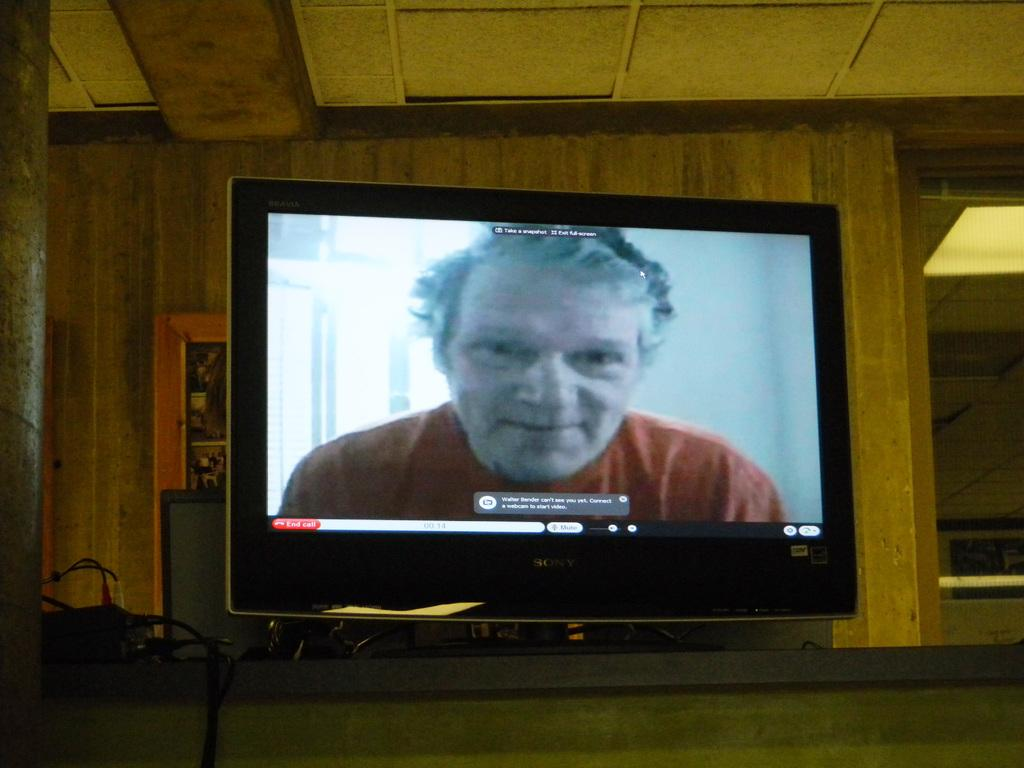<image>
Render a clear and concise summary of the photo. The subtitles below a man's face on the television screen begin with the letter W. 